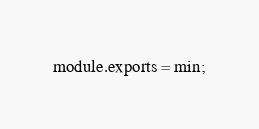<code> <loc_0><loc_0><loc_500><loc_500><_JavaScript_>module.exports = min;
</code> 